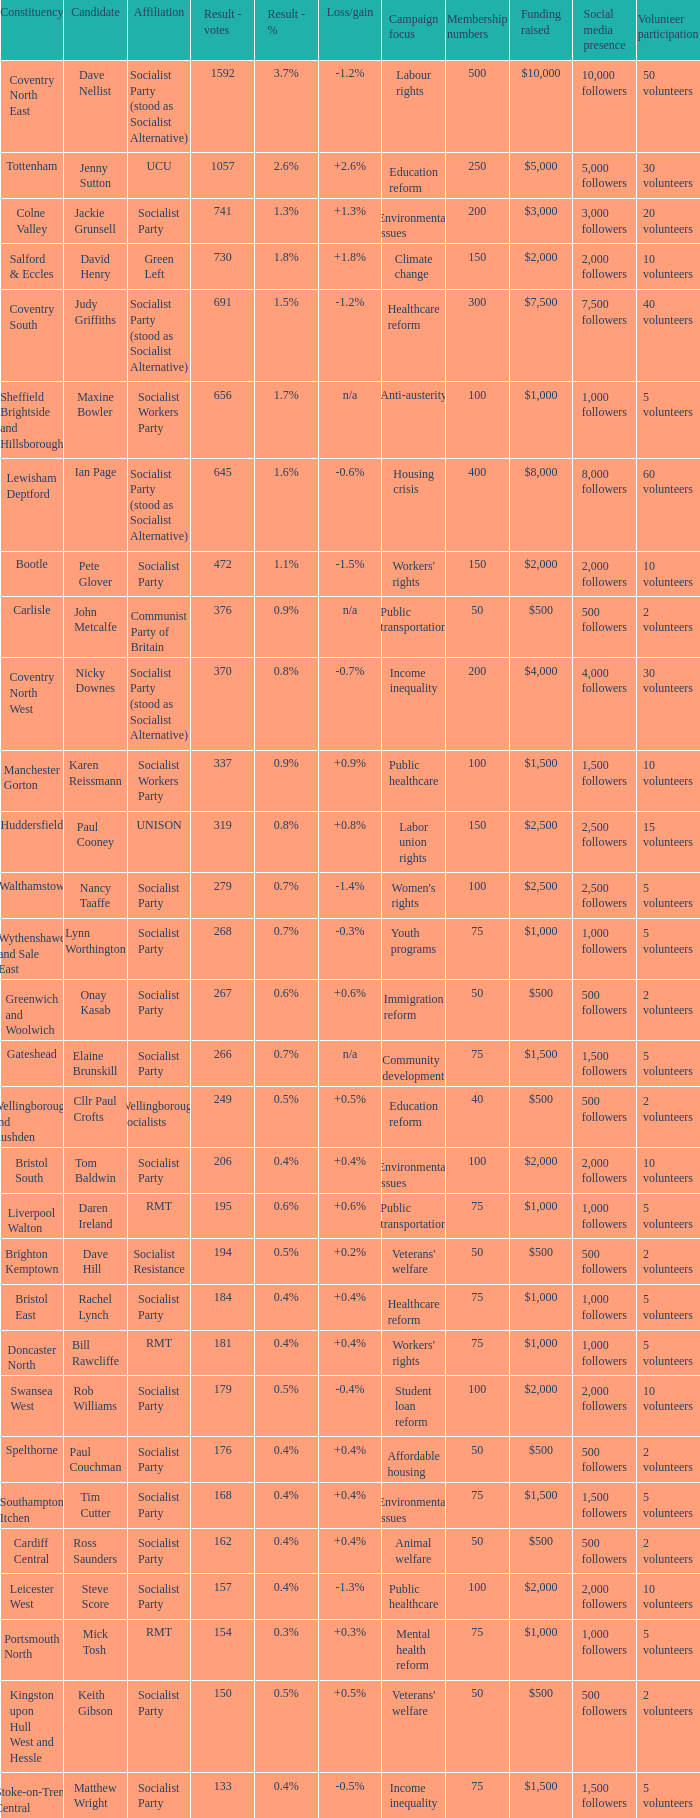What is every affiliation for the Tottenham constituency? UCU. 